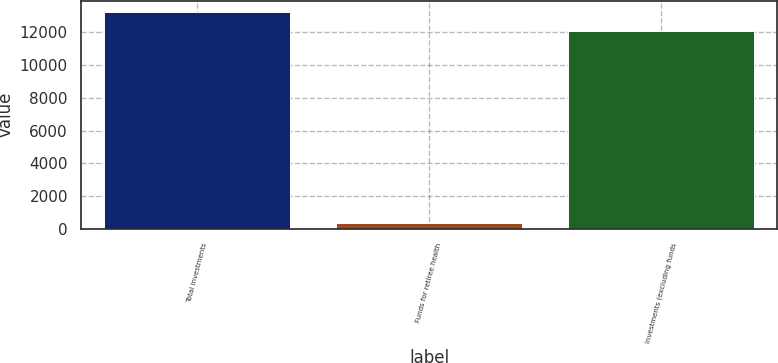Convert chart to OTSL. <chart><loc_0><loc_0><loc_500><loc_500><bar_chart><fcel>Total investments<fcel>Funds for retiree health<fcel>Investments (excluding funds<nl><fcel>13262.7<fcel>358<fcel>12057<nl></chart> 